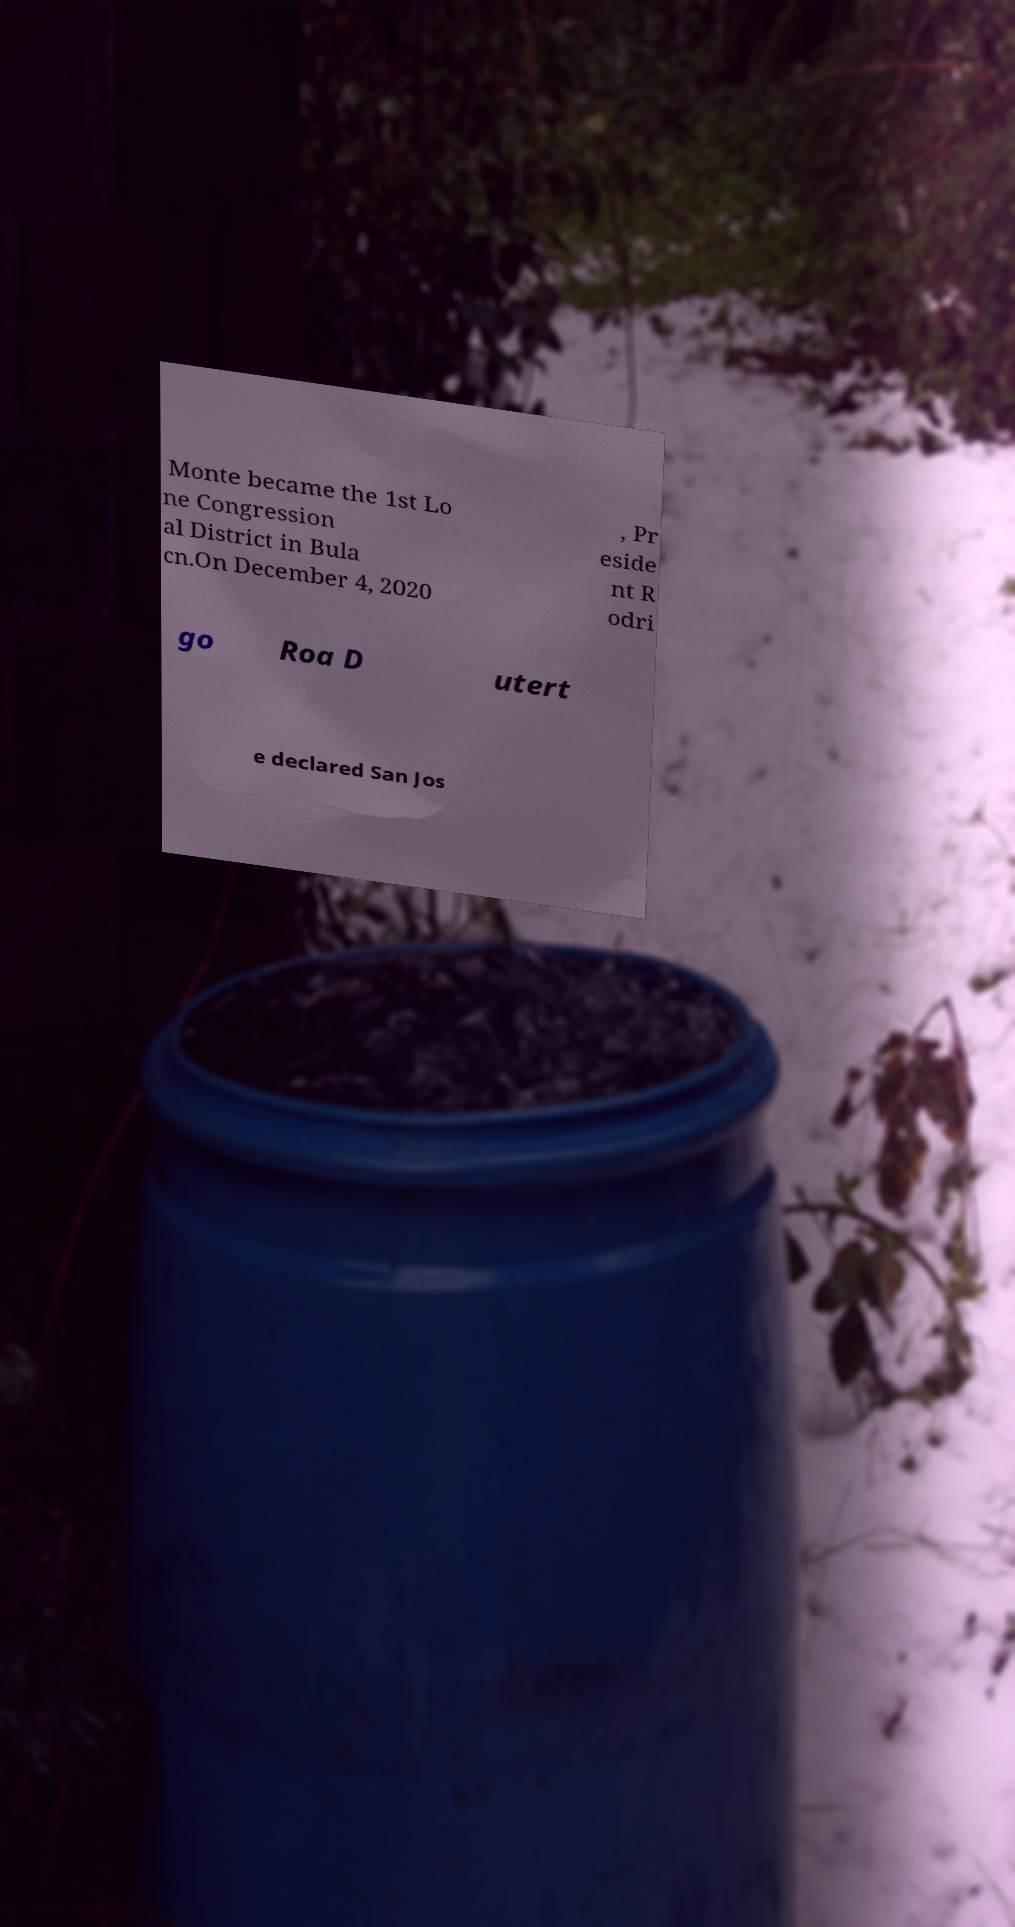Can you read and provide the text displayed in the image?This photo seems to have some interesting text. Can you extract and type it out for me? Monte became the 1st Lo ne Congression al District in Bula cn.On December 4, 2020 , Pr eside nt R odri go Roa D utert e declared San Jos 